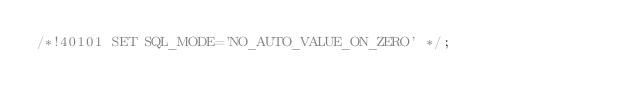Convert code to text. <code><loc_0><loc_0><loc_500><loc_500><_SQL_>/*!40101 SET SQL_MODE='NO_AUTO_VALUE_ON_ZERO' */;</code> 